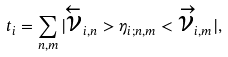<formula> <loc_0><loc_0><loc_500><loc_500>t _ { i } = \sum _ { n , m } | \overleftarrow { \nu } _ { i , n } > \eta _ { i ; n , m } < \overrightarrow { \nu } _ { i , m } | ,</formula> 